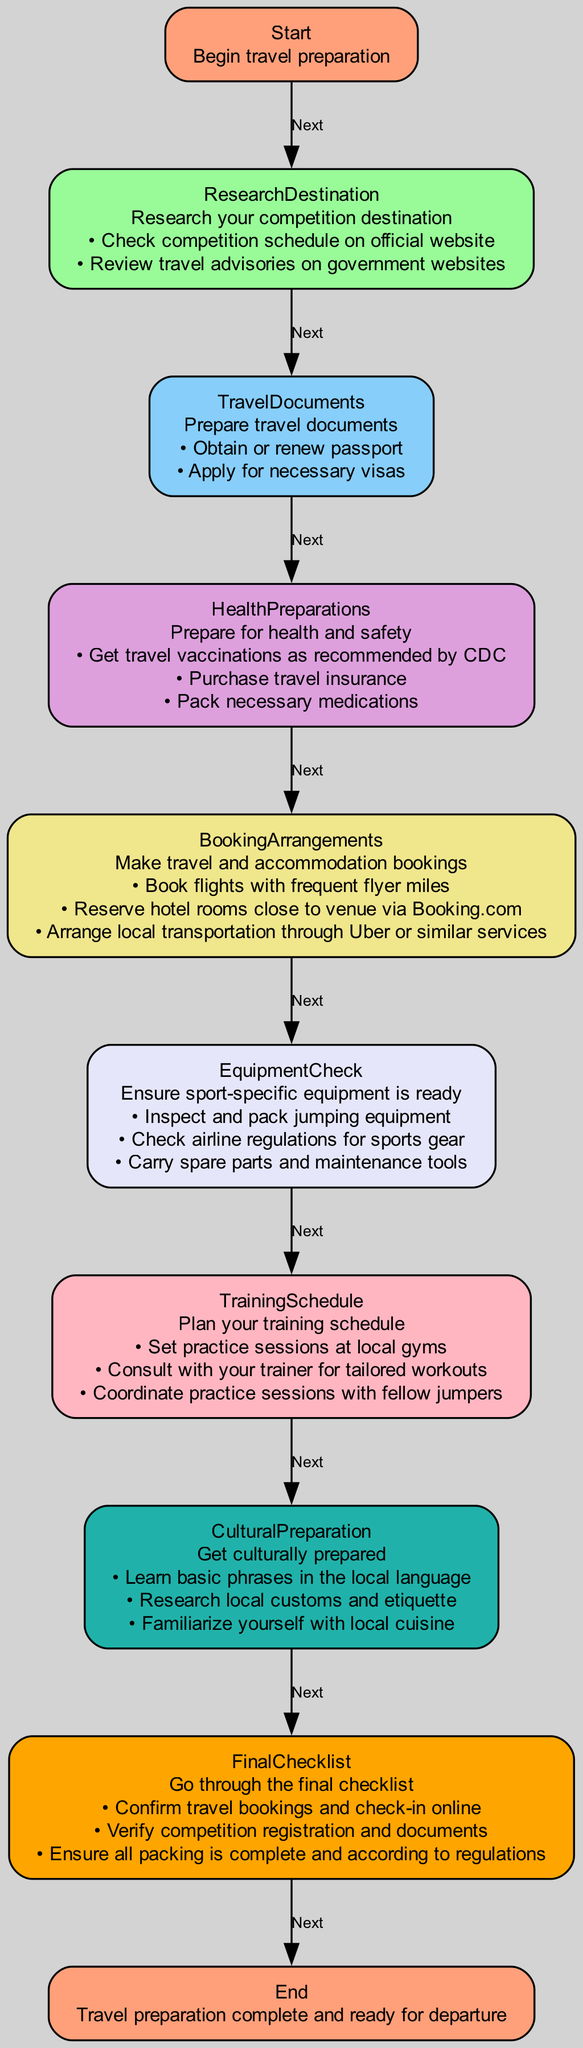What is the first step in the travel preparation process? The diagram begins with the "Start" node, which indicates the first step is to begin travel preparation.
Answer: Begin travel preparation How many actions are listed for "Health Preparations"? The "Health Preparations" node contains three actions listed, which are getting vaccinations, purchasing insurance, and packing medications.
Answer: Three What document needs to be obtained or renewed in the "Travel Documents" step? The "Travel Documents" step specifies that one must obtain or renew their passport.
Answer: Passport What is the last step before departing in the diagram? The flow chart indicates that the final step before departure is going through the "Final Checklist."
Answer: Final Checklist Which node directly follows the "Equipment Check" step? According to the diagram, the "Training Schedule" node follows the "Equipment Check" step directly in the flow.
Answer: Training Schedule What is the common action in both "Booking Arrangements" and "Health Preparations"? Both nodes include actions that involve preparation for the trip; specifically, "Booking Arrangements" includes booking flights and "Health Preparations" includes purchasing travel insurance.
Answer: Preparation How many nodes are there in total in this flow chart? By counting all the named nodes in the diagram, there are ten nodes from "Start" to "End."
Answer: Ten Which action comes after reviewing travel advisories? After reviewing travel advisories in the "Research Destination" step, the next step is "Travel Documents."
Answer: Travel Documents What is the purpose of the "Cultural Preparation" step? The "Cultural Preparation" step is designed for understanding and adapting to the local culture of the competition destination.
Answer: Understanding local culture 